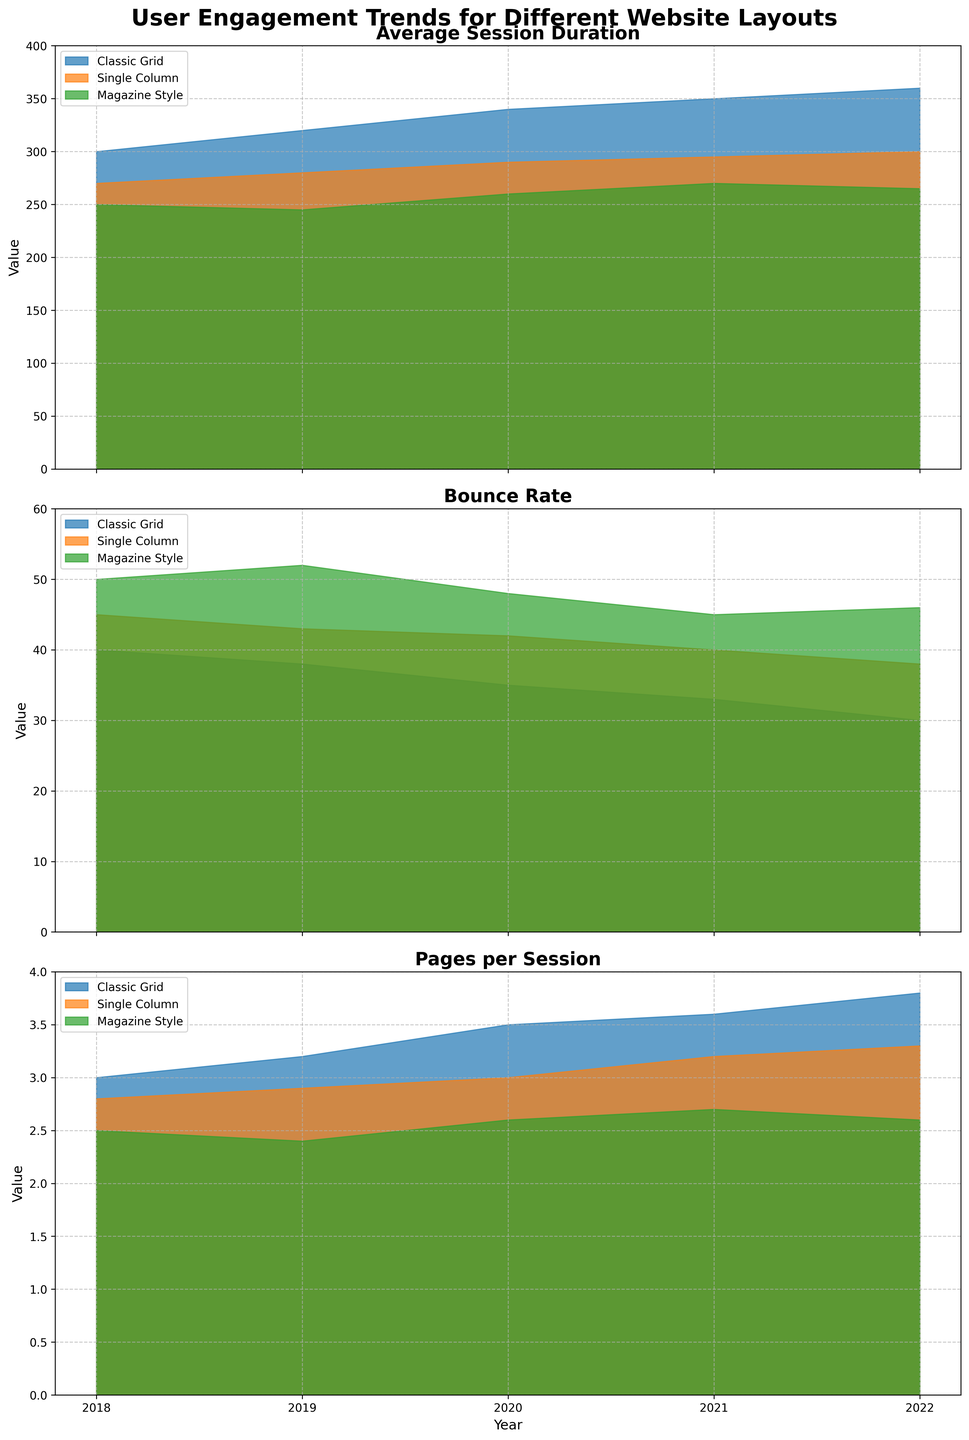What is the title of the plot? The title of the plot is displayed at the top of the figure. It reads "User Engagement Trends for Different Website Layouts," indicating the subject matter of the visual data presented.
Answer: User Engagement Trends for Different Website Layouts Which layout has the highest average session duration in 2022? The data for average session duration is shown in the top subplot. In 2022, the "Classic Grid" layout has the highest filled area indicating the highest average session duration.
Answer: Classic Grid How has the bounce rate for the "Single Column" layout changed from 2018 to 2022? In the second subplot, we can observe the "Single Column" layout's bounce rate decreasing from 45 in 2018 to 38 in 2022.
Answer: It decreased from 45 to 38 What is the overall trend for the "Average Session Duration" metric for all layouts from 2018 to 2022? Observing the top subplot, the filled areas for each layout grow over the years from 2018 to 2022, indicating an overall increase in average session duration for all layouts.
Answer: Increasing Between "Classic Grid" and "Magazine Style" layouts, which one has a lower bounce rate in 2020? Examining the second subplot for the year 2020, the filled area for "Classic Grid" is lower than that for "Magazine Style," indicating a lower bounce rate.
Answer: Classic Grid Which metric has the biggest difference in its values between "Classic Grid" and "Single Column" layouts in 2021? For this, we'll examine the filled areas in 2021 across the three subplots. For "Average Session Duration," the difference is 350 - 295 = 55. For "Bounce Rate," the difference is 33 - 40 = -7. For "Pages per Session," the difference is 3.6 - 3.2 = 0.4. Thus, the "Average Session Duration" has the biggest difference.
Answer: Average Session Duration What is the overall trend in the "Pages per Session" metric for the "Magazine Style" layout? In the third subplot, the filled area for "Magazine Style" shows a slight decrease from 2.5 in 2018 to around 2.6 in 2022, indicating a generally decreasing trend.
Answer: Decreasing Compare the slope of the average session duration between "Classic Grid" and "Single Column" layouts from 2018 to 2022. Which layout shows a steeper increase? From 2018 to 2022, the "Classic Grid" average session duration increases from 300 to 360, while "Single Column" increases from 270 to 300. The slope for "Classic Grid" is 60, and for "Single Column," it's 30. Thus, "Classic Grid" shows a steeper increase.
Answer: Classic Grid In which year does the "Pages per Session" metric for "Classic Grid" surpass 3.5 for the first time? Observing the third subplot, the filled area for "Classic Grid" first surpasses the 3.5 value line in 2020.
Answer: 2020 Which metric shows the least variation for the "Magazine Style" layout from 2018 to 2022? By examining the filled areas across the years for the "Magazine Style" layout in all subplots, the "Pages per Session" metric shows the least variation, remaining between 2.4 and 2.7.
Answer: Pages per Session 